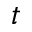<formula> <loc_0><loc_0><loc_500><loc_500>t</formula> 